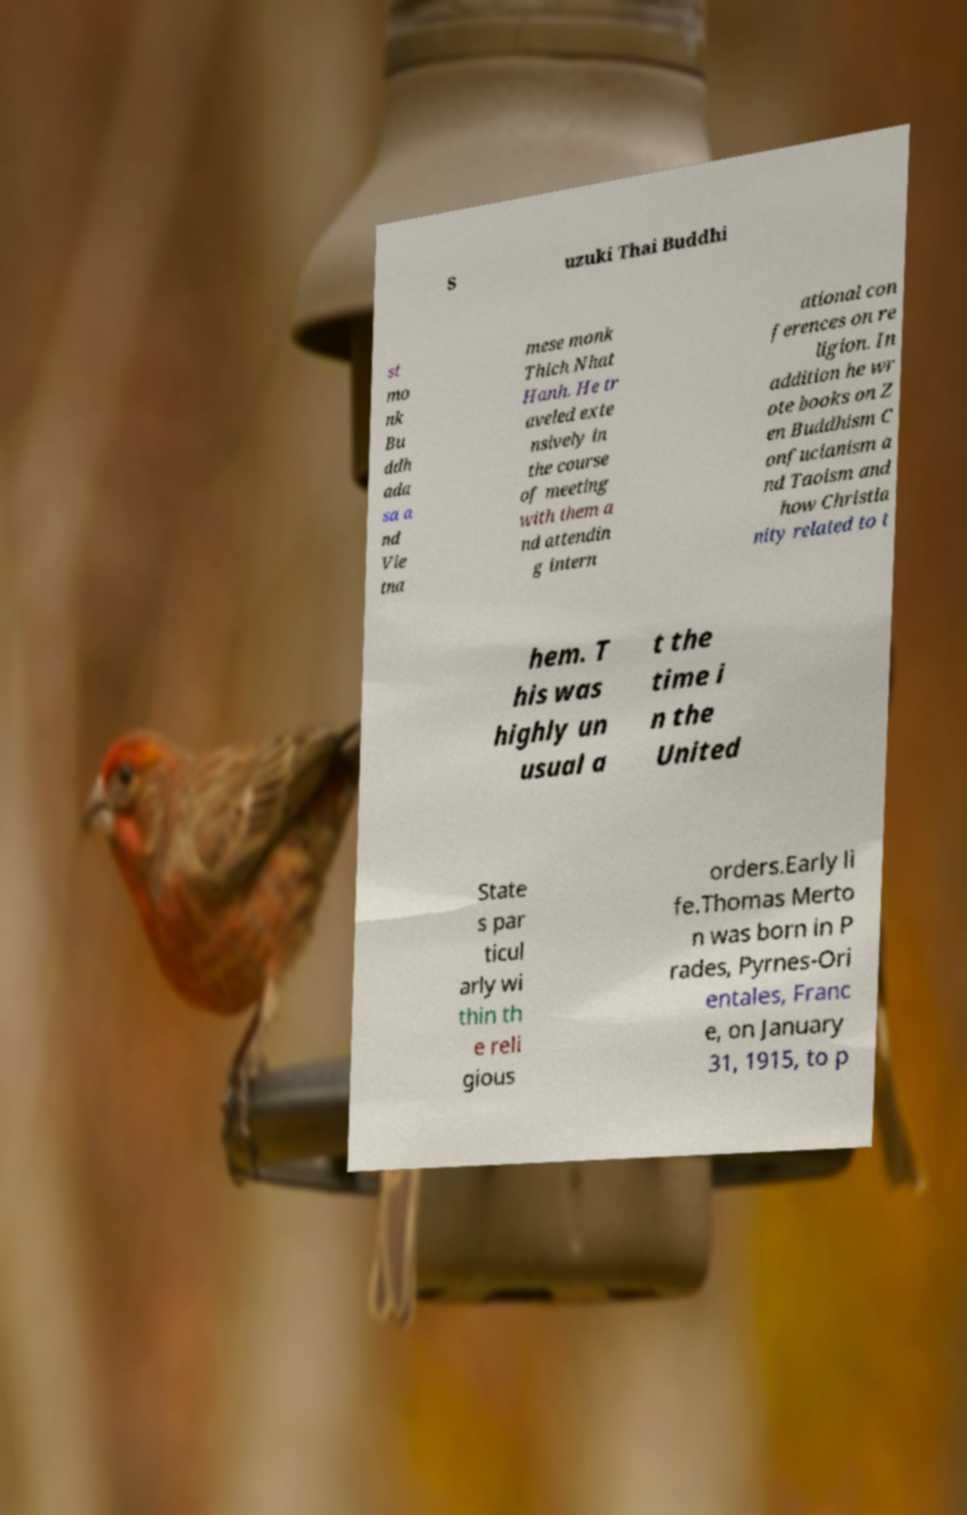What messages or text are displayed in this image? I need them in a readable, typed format. S uzuki Thai Buddhi st mo nk Bu ddh ada sa a nd Vie tna mese monk Thich Nhat Hanh. He tr aveled exte nsively in the course of meeting with them a nd attendin g intern ational con ferences on re ligion. In addition he wr ote books on Z en Buddhism C onfucianism a nd Taoism and how Christia nity related to t hem. T his was highly un usual a t the time i n the United State s par ticul arly wi thin th e reli gious orders.Early li fe.Thomas Merto n was born in P rades, Pyrnes-Ori entales, Franc e, on January 31, 1915, to p 